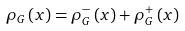<formula> <loc_0><loc_0><loc_500><loc_500>\rho _ { G } \left ( x \right ) = \rho _ { G } ^ { - } \left ( x \right ) + \rho _ { G } ^ { + } \left ( x \right )</formula> 